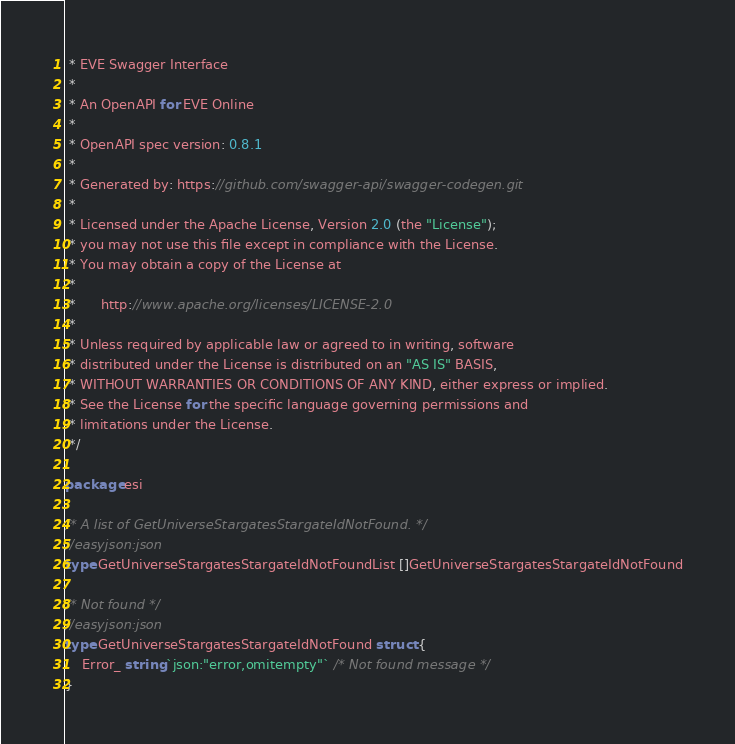Convert code to text. <code><loc_0><loc_0><loc_500><loc_500><_Go_> * EVE Swagger Interface
 *
 * An OpenAPI for EVE Online
 *
 * OpenAPI spec version: 0.8.1
 *
 * Generated by: https://github.com/swagger-api/swagger-codegen.git
 *
 * Licensed under the Apache License, Version 2.0 (the "License");
 * you may not use this file except in compliance with the License.
 * You may obtain a copy of the License at
 *
 *      http://www.apache.org/licenses/LICENSE-2.0
 *
 * Unless required by applicable law or agreed to in writing, software
 * distributed under the License is distributed on an "AS IS" BASIS,
 * WITHOUT WARRANTIES OR CONDITIONS OF ANY KIND, either express or implied.
 * See the License for the specific language governing permissions and
 * limitations under the License.
 */

package esi

/* A list of GetUniverseStargatesStargateIdNotFound. */
//easyjson:json
type GetUniverseStargatesStargateIdNotFoundList []GetUniverseStargatesStargateIdNotFound

/* Not found */
//easyjson:json
type GetUniverseStargatesStargateIdNotFound struct {
	Error_ string `json:"error,omitempty"` /* Not found message */
}
</code> 